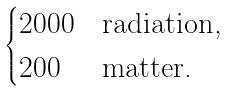Convert formula to latex. <formula><loc_0><loc_0><loc_500><loc_500>\begin{cases} 2 0 0 0 & \text {radiation,} \\ 2 0 0 & \text {matter.} \end{cases}</formula> 